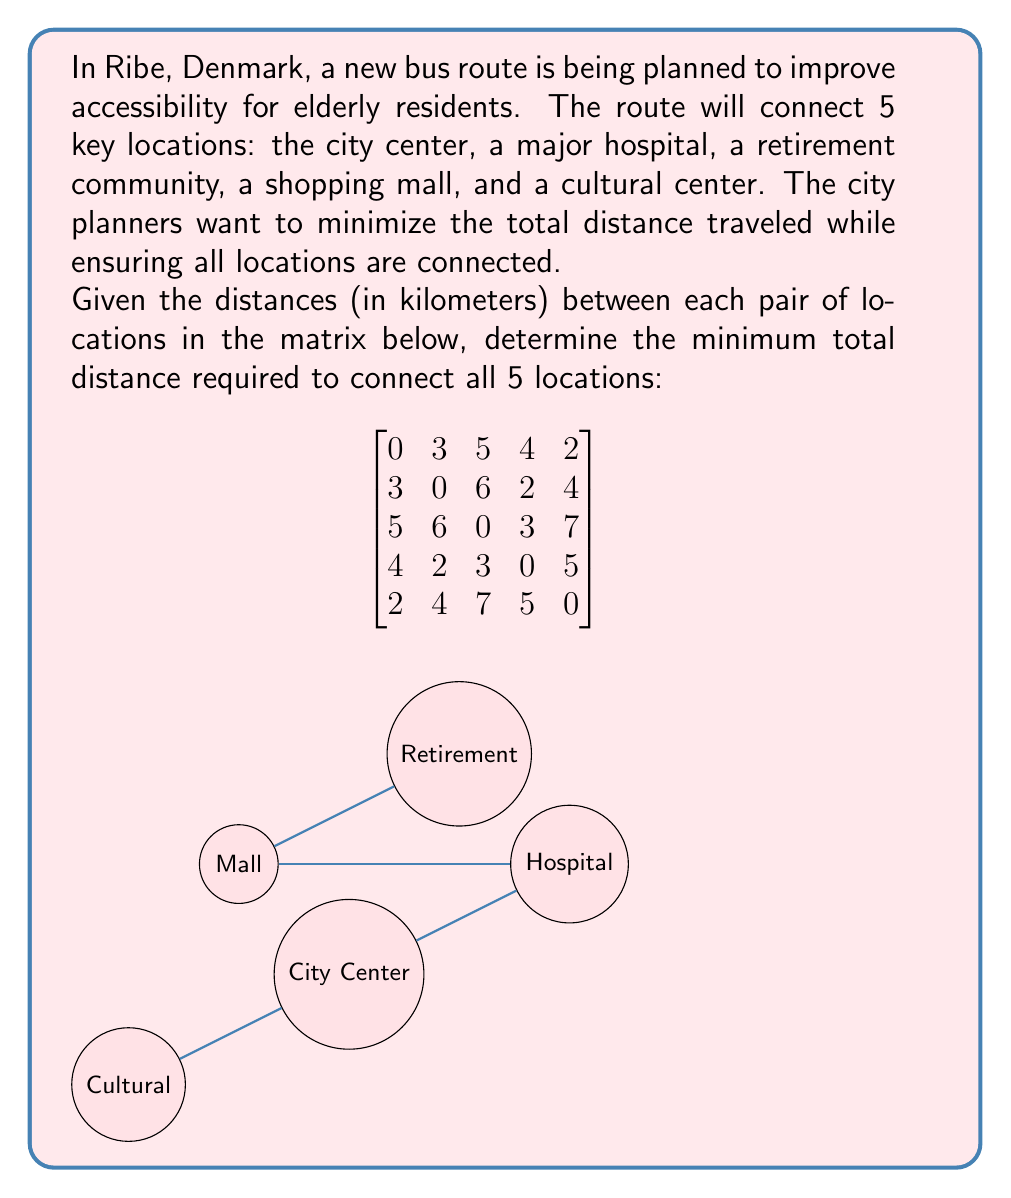What is the answer to this math problem? To solve this problem, we need to find the minimum spanning tree of the graph represented by the distance matrix. We can use Kruskal's algorithm:

1) Sort all edges in ascending order of weight:
   (0,4): 2km
   (1,3): 2km
   (0,1): 3km
   (2,3): 3km
   (0,3): 4km
   (1,4): 4km
   ...

2) Start with an empty set of edges and add edges one by one:
   a) Add (0,4): 2km (connects City Center and Cultural Center)
   b) Add (1,3): 2km (connects Hospital and Mall)
   c) Add (0,1): 3km (connects City Center and Hospital)
   d) Add (2,3): 3km (connects Retirement Community and Mall)

3) We now have all 5 vertices connected with 4 edges, so we stop.

4) Calculate the total distance:
   $$ \text{Total Distance} = 2 + 2 + 3 + 3 = 10\text{ km} $$

This solution ensures all locations are connected while minimizing the total distance traveled, which is crucial for efficient public transportation, especially for elderly accessibility.
Answer: 10 km 